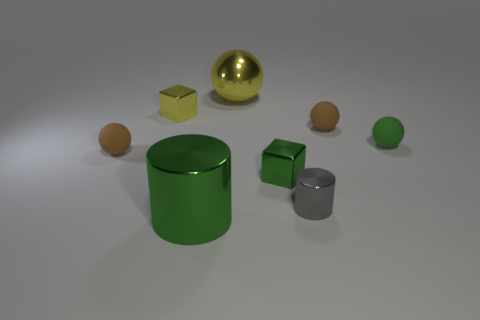There is a small metallic cylinder; does it have the same color as the small shiny thing on the left side of the green metal cylinder?
Your response must be concise. No. There is a green shiny cylinder on the left side of the green rubber thing; what number of metal cubes are to the right of it?
Your response must be concise. 1. Is there any other thing that has the same material as the tiny gray thing?
Give a very brief answer. Yes. What is the tiny block that is right of the sphere that is behind the yellow metallic object that is in front of the large yellow sphere made of?
Your answer should be very brief. Metal. There is a object that is both in front of the small green metallic object and on the right side of the green block; what is it made of?
Keep it short and to the point. Metal. How many small yellow shiny things have the same shape as the small green rubber thing?
Your answer should be compact. 0. There is a yellow shiny object in front of the large metal thing behind the small yellow block; how big is it?
Offer a terse response. Small. Is the color of the block that is in front of the green rubber ball the same as the big metal object in front of the green rubber sphere?
Keep it short and to the point. Yes. What number of small balls are behind the tiny brown object in front of the tiny brown ball that is on the right side of the green cylinder?
Your response must be concise. 2. How many green objects are behind the green metal cylinder and in front of the green rubber sphere?
Offer a very short reply. 1. 